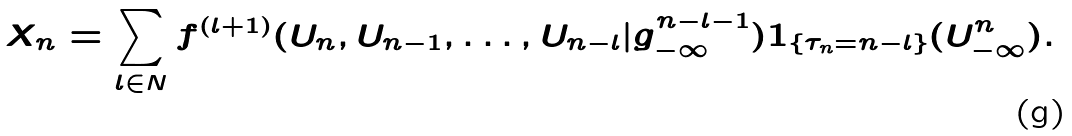Convert formula to latex. <formula><loc_0><loc_0><loc_500><loc_500>X _ { n } = \sum _ { l \in N } f ^ { \left ( l + 1 \right ) } ( U _ { n } , U _ { n - 1 } , \dots , U _ { n - l } | g _ { - \infty } ^ { n - l - 1 } ) 1 _ { \{ \tau _ { n } = n - l \} } ( U ^ { n } _ { - \infty } ) .</formula> 